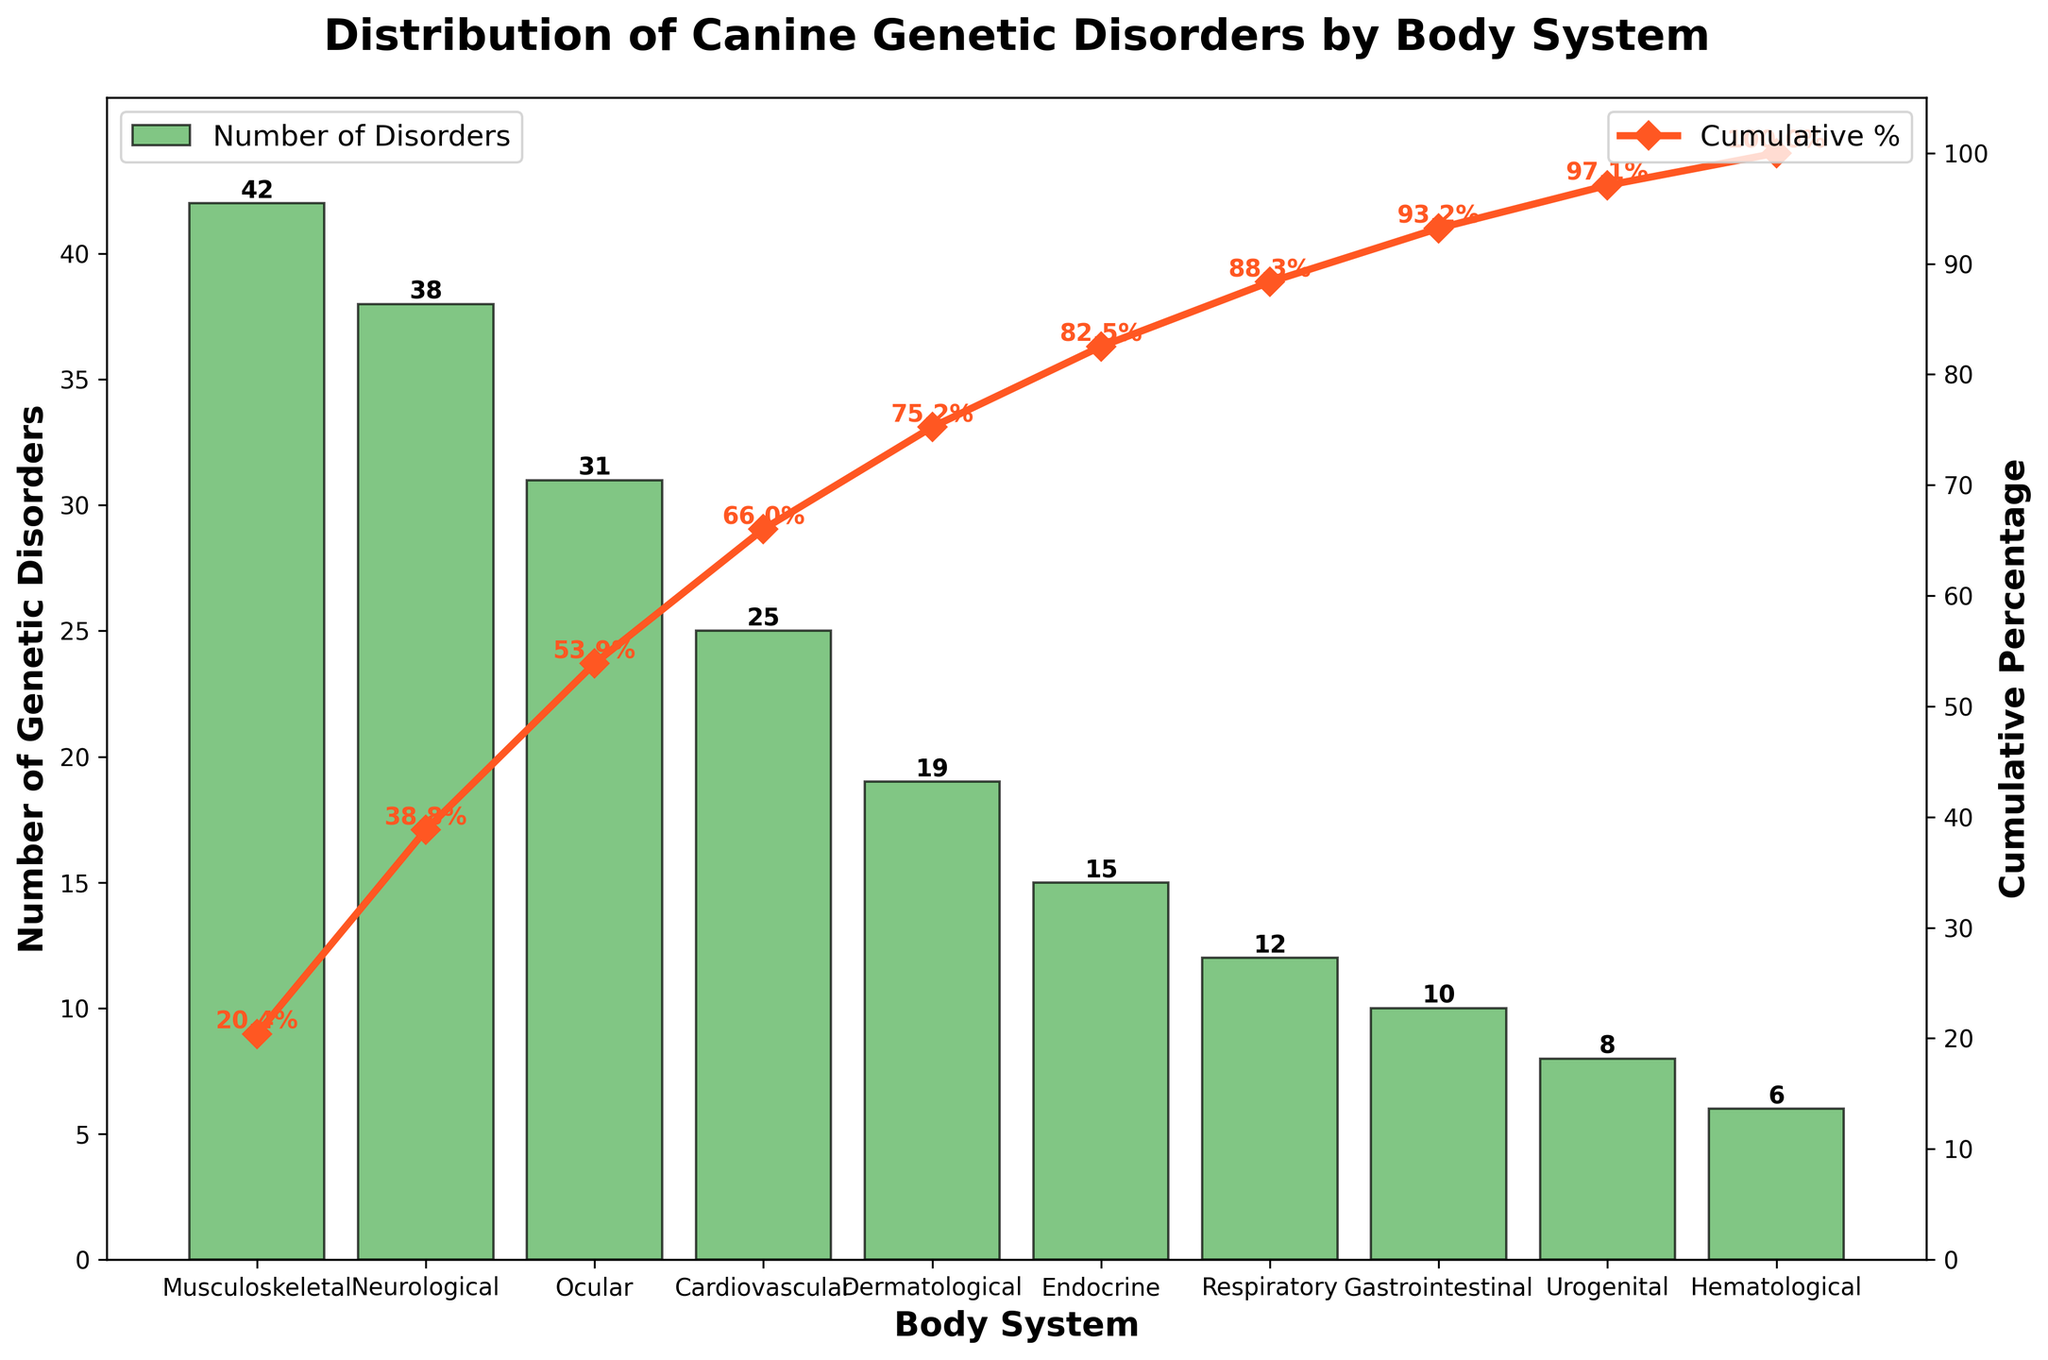What body system has the highest number of genetic disorders? The highest bar in the chart represents the body system with the most genetic disorders, which is labeled "Musculoskeletal" with 42 disorders.
Answer: Musculoskeletal What is the cumulative percentage after the "Ocular" body system? The cumulative percentage line for "Ocular" can be located and read from the secondary y-axis; it corresponds to approximately 72%.
Answer: About 72% How many genetic disorders are associated with the "Cardiovascular" body system? The bar for "Cardiovascular" shows the height corresponding to its value, which is 25.
Answer: 25 Which body system has fewer genetic disorders, "Endocrine" or "Respiratory"? Comparing the heights of the bars for "Endocrine" and "Respiratory," "Endocrine" has a taller bar with 15 disorders compared to "Respiratory" with 12 disorders.
Answer: Respiratory What is the combined number of genetic disorders for "Dermatological" and "Urogenital" body systems? Adding the values for "Dermatological" (19) and "Urogenital" (8) results in 19 + 8 = 27.
Answer: 27 After adding the first three body systems, what percentage of the total genetic disorders are accounted for? The cumulative percentages for "Musculoskeletal," "Neurological," and "Ocular" can be found and added: approximately 28%, 52%, and 72%, respectively. The first three cumulative percentages give the estimate of 72%.
Answer: About 72% Which body system has the lowest number of genetic disorders? The shortest bar in the chart corresponds to the "Hematological" body system, which has 6 disorders.
Answer: Hematological How does the number of genetic disorders in the "Neurological" system compare to the "Gastrointestinal" system? The bar representing "Neurological" has 38 disorders, while "Gastrointestinal" has 10. The difference is 38 - 10 = 28 disorders.
Answer: 28 more in Neurological What percentage is reached after the "Endocrine" body system in the cumulative line? The percentage value for “Endocrine” can be read from the cumulative percentage line, which is around 85%.
Answer: About 85% If the number of genetic disorders in "Musculoskeletal" doubled, what would the new cumulative percentage be at "Musculoskeletal"? Doubling the disorders in "Musculoskeletal" from 42 to 84, the new total becomes 42 + 84 = 126. Adding this to the original total genetic disorders (206) gives 248. The new percentage for "Musculoskeletal" disorders alone would be (84/248*100) = 33.87%.
Answer: About 33.9% 